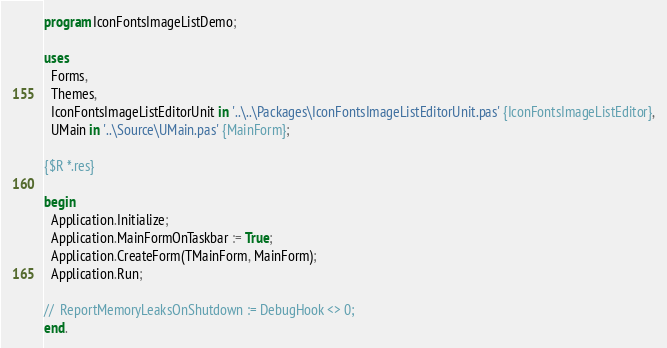<code> <loc_0><loc_0><loc_500><loc_500><_Pascal_>program IconFontsImageListDemo;

uses
  Forms,
  Themes,
  IconFontsImageListEditorUnit in '..\..\Packages\IconFontsImageListEditorUnit.pas' {IconFontsImageListEditor},
  UMain in '..\Source\UMain.pas' {MainForm};

{$R *.res}

begin
  Application.Initialize;
  Application.MainFormOnTaskbar := True;
  Application.CreateForm(TMainForm, MainForm);
  Application.Run;

//  ReportMemoryLeaksOnShutdown := DebugHook <> 0;
end.
</code> 